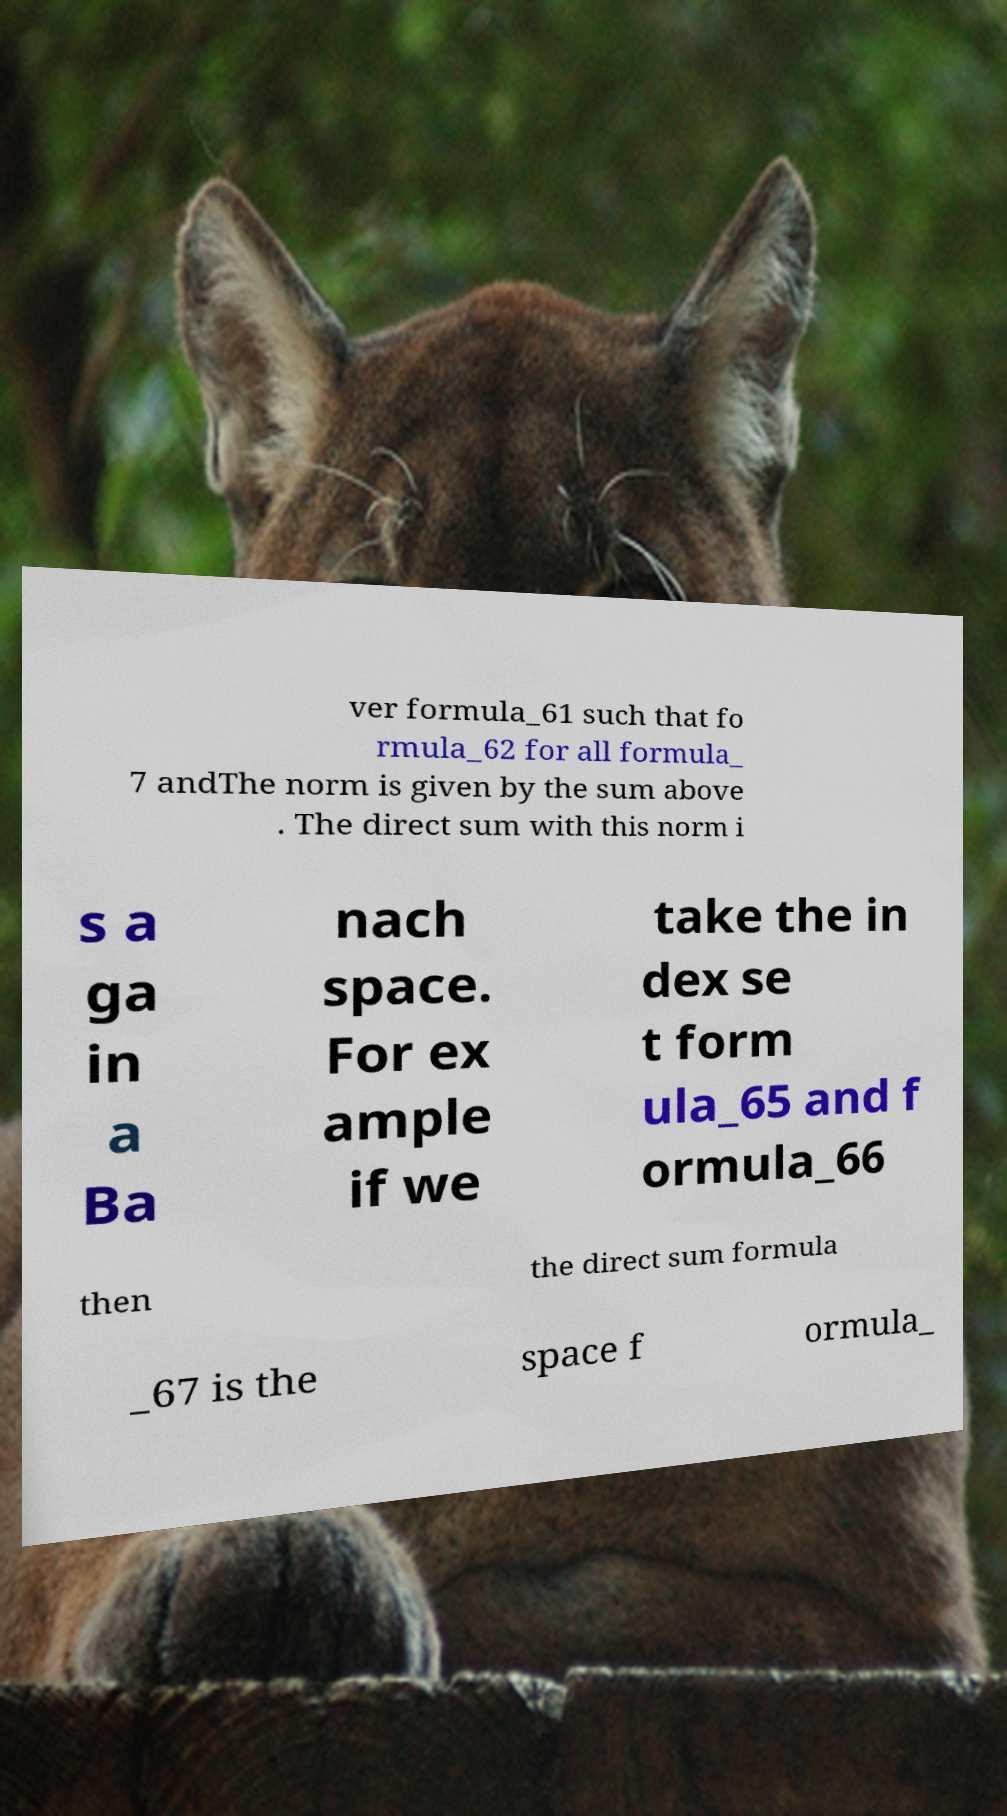Can you read and provide the text displayed in the image?This photo seems to have some interesting text. Can you extract and type it out for me? ver formula_61 such that fo rmula_62 for all formula_ 7 andThe norm is given by the sum above . The direct sum with this norm i s a ga in a Ba nach space. For ex ample if we take the in dex se t form ula_65 and f ormula_66 then the direct sum formula _67 is the space f ormula_ 